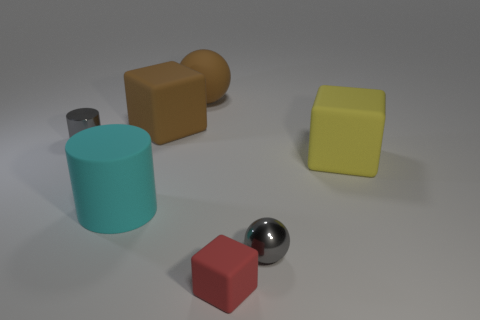What number of blocks are the same color as the large ball?
Offer a very short reply. 1. There is a big thing that is the same color as the large sphere; what is its material?
Your answer should be compact. Rubber. There is a gray shiny thing that is behind the tiny metal object that is to the right of the small shiny thing that is to the left of the red matte object; what is its size?
Your answer should be very brief. Small. Are there any large blocks that are behind the big block that is to the right of the brown block?
Give a very brief answer. Yes. There is a tiny rubber thing; is its shape the same as the large rubber object that is to the right of the tiny red rubber thing?
Your response must be concise. Yes. What color is the sphere that is behind the small cylinder?
Your response must be concise. Brown. There is a sphere behind the object that is to the left of the large cylinder; what is its size?
Your answer should be very brief. Large. Do the tiny gray shiny object behind the big yellow block and the red rubber thing have the same shape?
Ensure brevity in your answer.  No. There is a gray thing that is the same shape as the cyan object; what is its material?
Your answer should be compact. Metal. What number of things are blocks to the left of the large rubber sphere or spheres on the left side of the small red thing?
Provide a short and direct response. 2. 